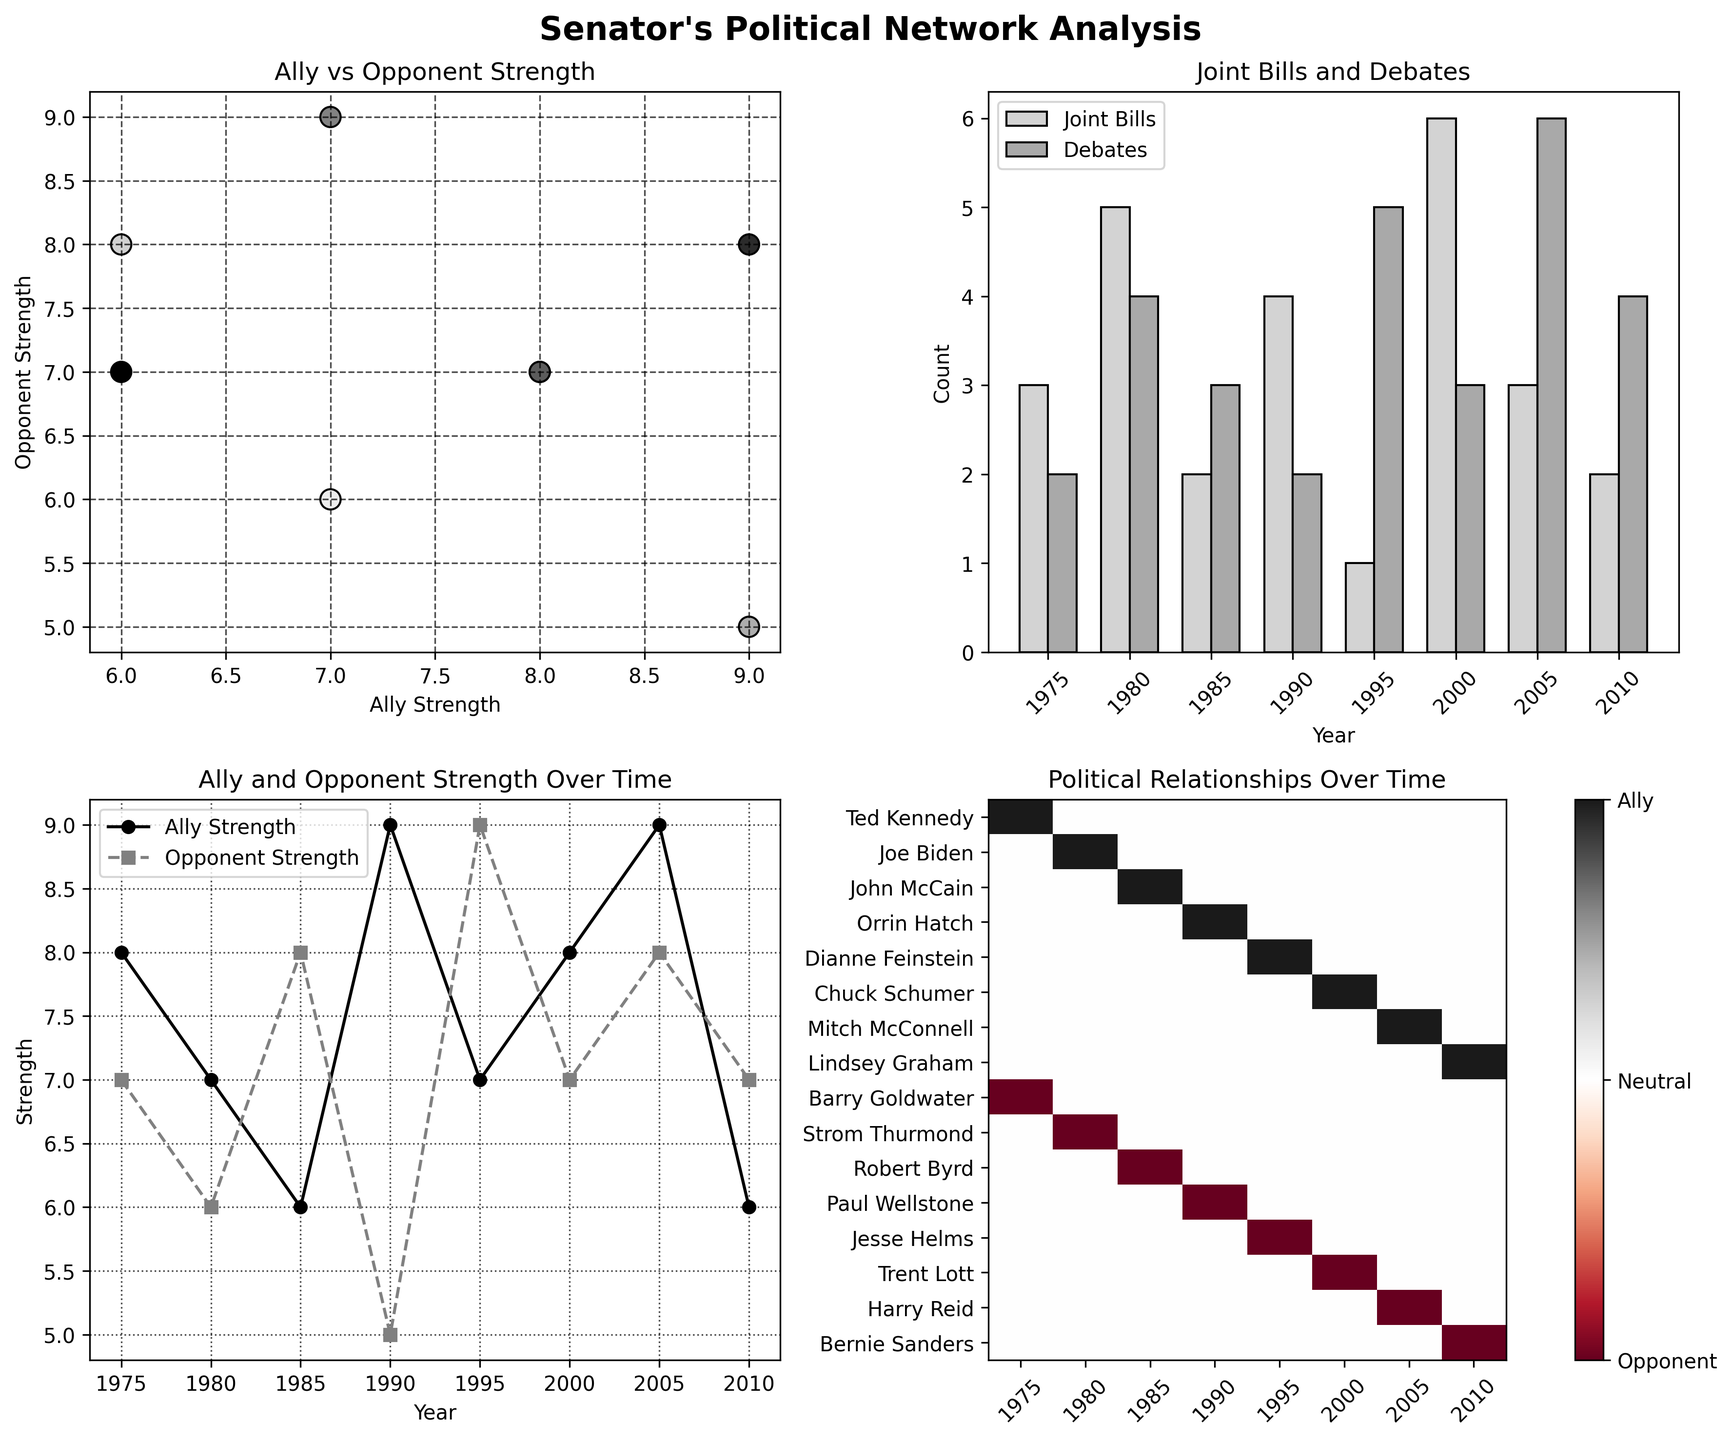What's the main title of the figure? The main title is located at the top of the figure in large bold font and gives an overview of the entire figure. It is “Senator's Political Network Analysis”.
Answer: Senator's Political Network Analysis Which year had the highest number of joint bills? In the "Joint Bills and Debates" bar plot, we look at the height of the bars representing joint bills. The year with the tallest bar for joint bills is 2000.
Answer: 2000 Are ally strengths generally higher than opponent strengths over time? By observing the "Ally and Opponent Strength Over Time" line plot, we compare the two lines. The ally strength (solid line) is generally above the opponent strength (dashed line) across most years.
Answer: Yes Which ally had the highest strength and in which year? In the "Ally vs Opponent Strength" scatter plot, the highest value on the x-axis indicates the highest ally strength. This point corresponds to Orrin Hatch in 1990 with an ally strength of 9.
Answer: Orrin Hatch, 1990 How many total debates were there in the years 1985 and 2010 combined? From the "Joint Bills and Debates" bar plot, locate the bars for 1985 and 2010 representing debates. The counts are 3 and 4, respectively. Adding them gives us 3 + 4 = 7.
Answer: 7 Which year shows the highest activity in terms of both joint bills and debates? In the "Joint Bills and Debates" bar plot, sum the heights for joint bills and debates for each year. The year 2000 has the highest combined total with 6 joint bills and 3 debates, totaling 9 activities.
Answer: 2000 Did the senator have more political interactions with allies or opponents in 2005? Look at the "Political Relationships Over Time" heatmap for the year 2005. Both Mitch McConnell (ally) and Harry Reid (opponent) are marked. Counting their connections, both ally and opponent interactions appear the same.
Answer: Equal 